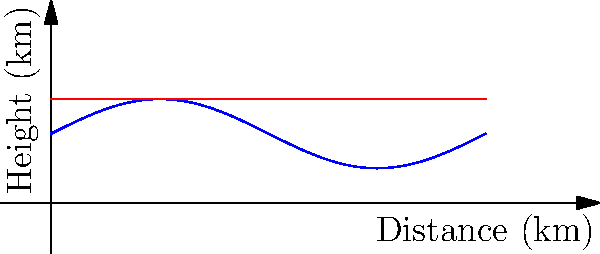Given the terrain profile represented by the blue curve $y = 0.5\sin(x) + 1$ and a signal path represented by the red line $y = 1.5$, determine the total length of the signal path that is above the terrain over a distance of $2\pi$ km. How does this compare to the direct line-of-sight distance? To solve this problem, we need to follow these steps:

1) First, we need to find the points where the signal path intersects the terrain. This occurs when:

   $1.5 = 0.5\sin(x) + 1$
   $0.5 = 0.5\sin(x)$
   $\sin(x) = 1$

   This occurs at $x = \frac{\pi}{2}$ and $x = \frac{5\pi}{2}$.

2) The length of the signal path above the terrain is the distance between these two points:

   $\frac{5\pi}{2} - \frac{\pi}{2} = 2\pi$

3) The direct line-of-sight distance is also $2\pi$, as this is the total distance covered.

4) Therefore, the length of the signal path above the terrain is equal to the direct line-of-sight distance.

This result suggests that the signal path is optimally placed to maximize its distance above the terrain, which would likely result in stronger and clearer signal transmission.
Answer: $2\pi$ km, equal to line-of-sight distance 